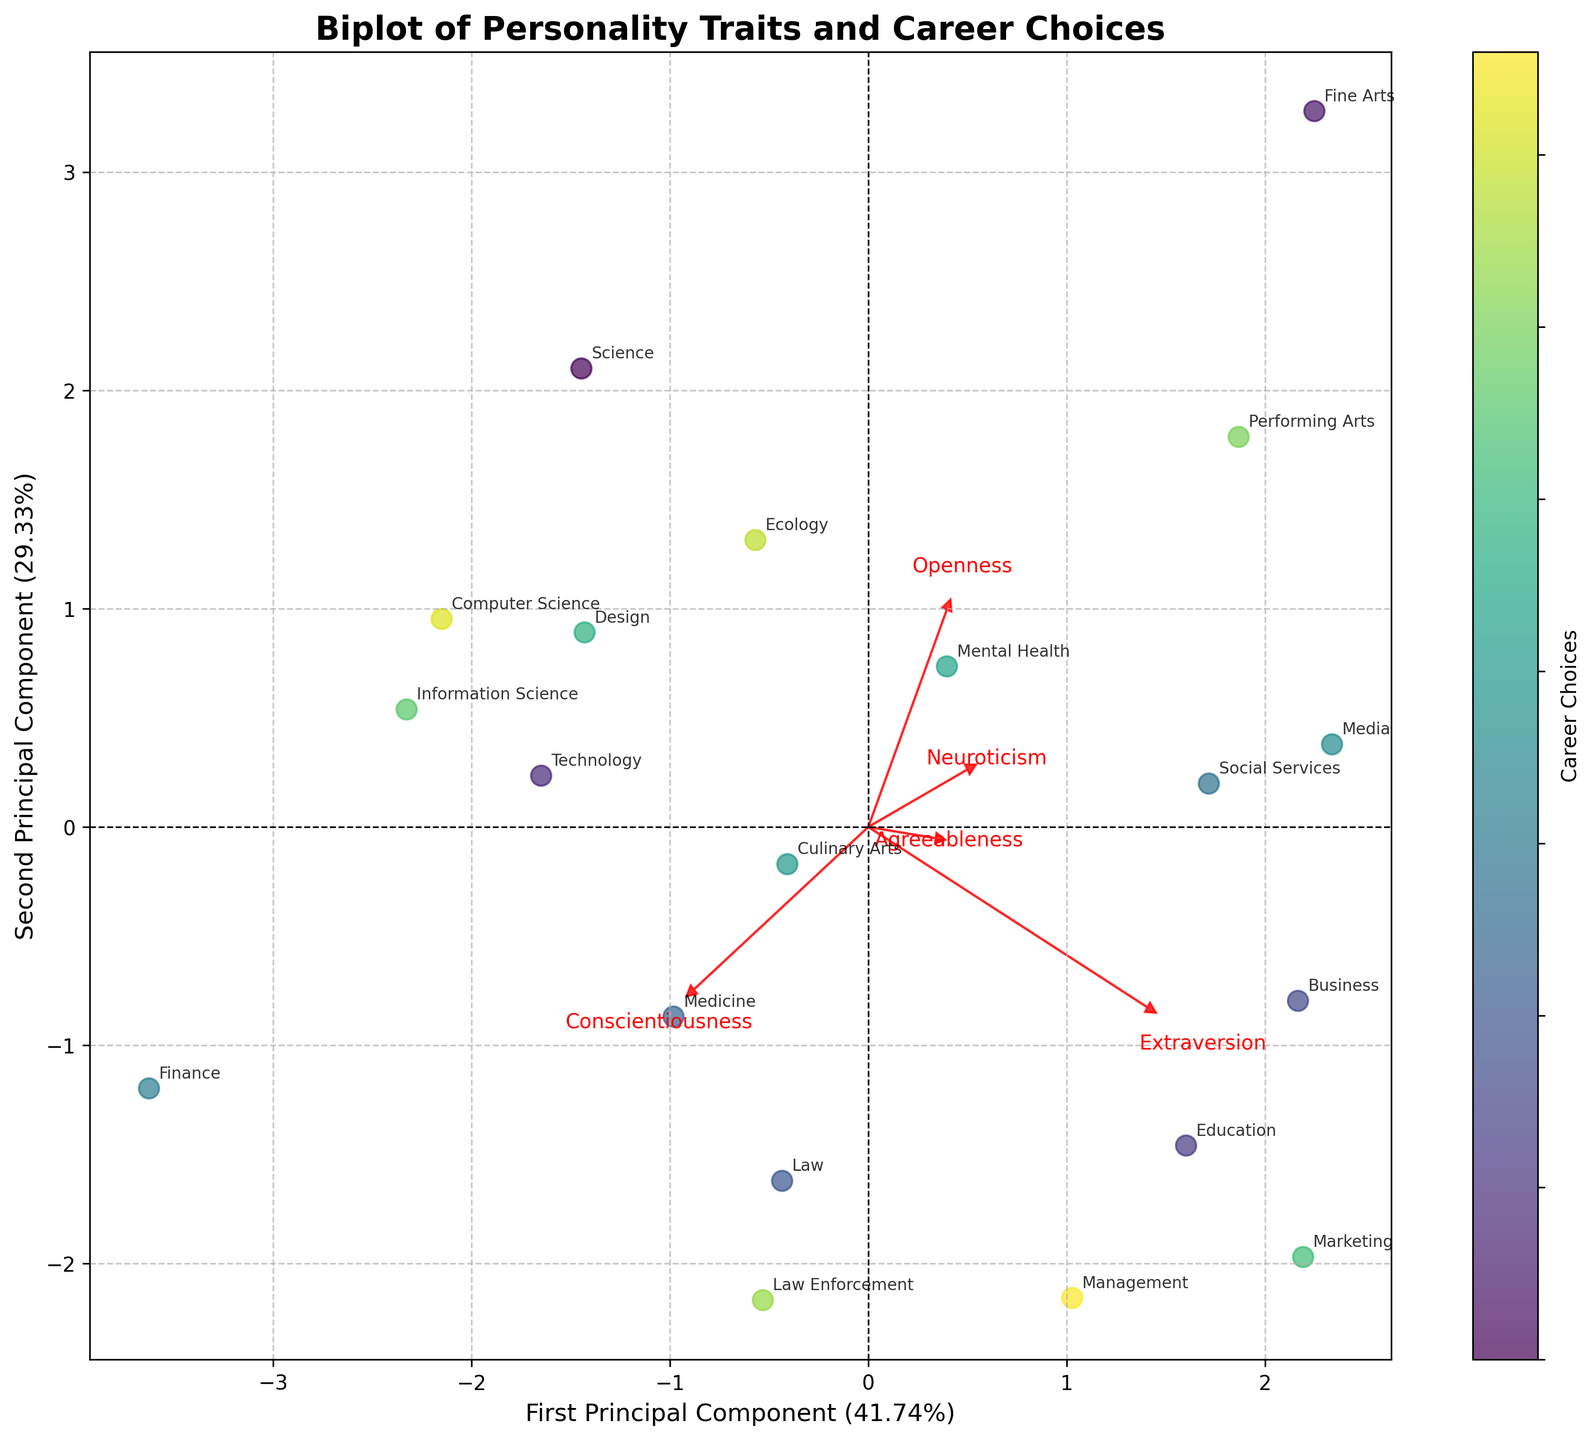What is the title of the figure? The title is typically found at the top of the figure and provides a brief summary of what the figure represents.
Answer: Biplot of Personality Traits and Career Choices How many career choices are represented in the figure? Each data point on the biplot corresponds to a career choice. Counting these points will give the total number.
Answer: 20 Which personality trait has the highest loading on the first principal component? By examining the arrows representing the loadings, the trait with the arrow pointing furthest along the x-axis indicates the highest loading on the first principal component.
Answer: Openness Which career choice is closest to the center of the plot? The career choice closest to the intersection of the x and y axes (0,0) is the one closest to the center.
Answer: Software Developer Is ‘Teacher’ more aligned with ‘Agreeableness’ or ‘Extraversion’? Check the direction of the vector arrows representing ‘Agreeableness’ and ‘Extraversion’ and see where ‘Teacher’ is positioned in relation to these arrows.
Answer: Extraversion How much variance is explained by the second principal component? This information is typically labeled on the y-axis of the biplot as a percentage.
Answer: The exact percentage, as indicated on the y-axis (for example, if the y-axis states "Second Principal Component (XX.XX%)") Which career choice is highly influenced by both ‘Openness’ and ‘Extraversion’? Find the data point that lies in the direction of both ‘Openness’ and ‘Extraversion’ arrows.
Answer: Entrepreneur Between 'Artist' and 'Lawyer', which career choice is more associated with ‘Neuroticism’? Compare the positions of 'Artist' and 'Lawyer' about the 'Neuroticism' arrow to see which is closer or more aligned.
Answer: Artist What does the color of the data points represent in the plot? Examine the legend or color bar in the figure to understand what is mapped to the colors of the data points.
Answer: Career Choices Which personality trait has the least influence on career choices based on the length of the corresponding arrow? The shortest arrow among the trait vectors represents the trait with the least influence.
Answer: Neuroticism 